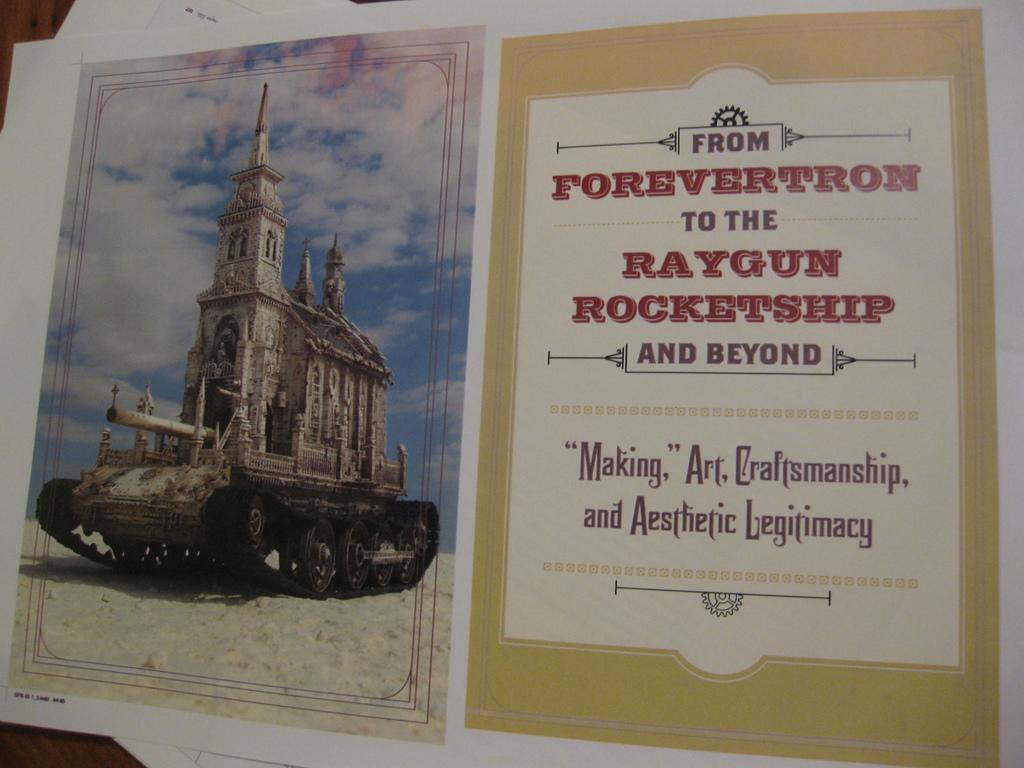What is the first word at the top of the flyer?
Provide a short and direct response. From. 